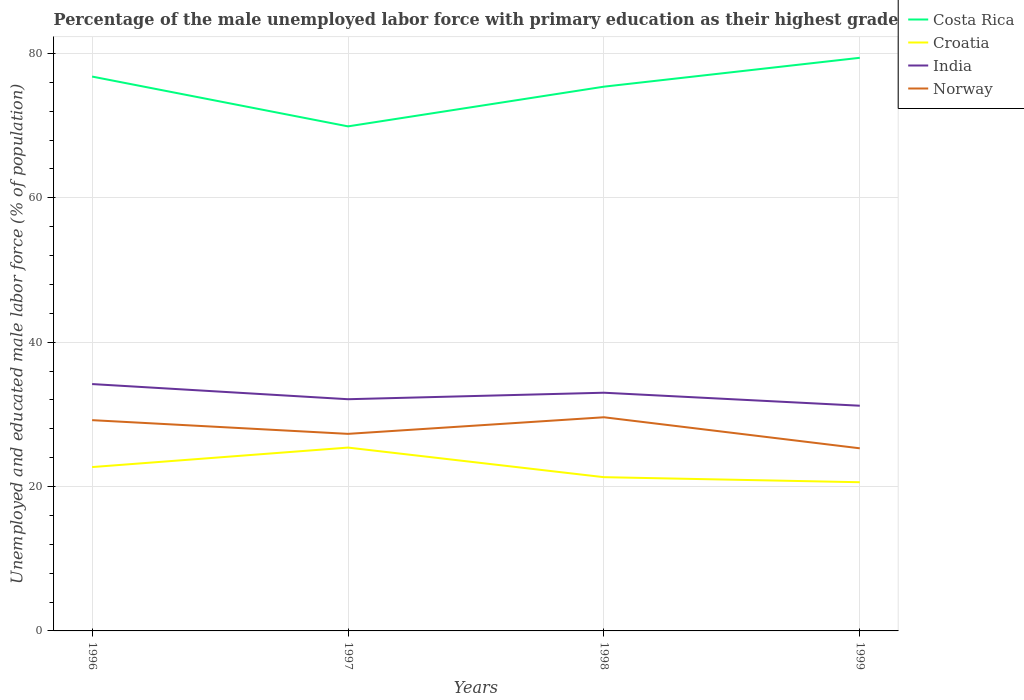Does the line corresponding to India intersect with the line corresponding to Norway?
Keep it short and to the point. No. Across all years, what is the maximum percentage of the unemployed male labor force with primary education in Norway?
Provide a short and direct response. 25.3. In which year was the percentage of the unemployed male labor force with primary education in India maximum?
Offer a very short reply. 1999. What is the total percentage of the unemployed male labor force with primary education in Costa Rica in the graph?
Your response must be concise. 6.9. What is the difference between the highest and the second highest percentage of the unemployed male labor force with primary education in India?
Ensure brevity in your answer.  3. What is the difference between the highest and the lowest percentage of the unemployed male labor force with primary education in Costa Rica?
Give a very brief answer. 3. What is the difference between two consecutive major ticks on the Y-axis?
Give a very brief answer. 20. Does the graph contain any zero values?
Give a very brief answer. No. How many legend labels are there?
Offer a terse response. 4. How are the legend labels stacked?
Your answer should be compact. Vertical. What is the title of the graph?
Keep it short and to the point. Percentage of the male unemployed labor force with primary education as their highest grade. Does "Grenada" appear as one of the legend labels in the graph?
Provide a short and direct response. No. What is the label or title of the Y-axis?
Provide a succinct answer. Unemployed and educated male labor force (% of population). What is the Unemployed and educated male labor force (% of population) of Costa Rica in 1996?
Your answer should be very brief. 76.8. What is the Unemployed and educated male labor force (% of population) in Croatia in 1996?
Give a very brief answer. 22.7. What is the Unemployed and educated male labor force (% of population) of India in 1996?
Give a very brief answer. 34.2. What is the Unemployed and educated male labor force (% of population) in Norway in 1996?
Provide a short and direct response. 29.2. What is the Unemployed and educated male labor force (% of population) in Costa Rica in 1997?
Your response must be concise. 69.9. What is the Unemployed and educated male labor force (% of population) of Croatia in 1997?
Offer a terse response. 25.4. What is the Unemployed and educated male labor force (% of population) of India in 1997?
Your answer should be very brief. 32.1. What is the Unemployed and educated male labor force (% of population) of Norway in 1997?
Provide a short and direct response. 27.3. What is the Unemployed and educated male labor force (% of population) in Costa Rica in 1998?
Your answer should be very brief. 75.4. What is the Unemployed and educated male labor force (% of population) of Croatia in 1998?
Offer a very short reply. 21.3. What is the Unemployed and educated male labor force (% of population) of Norway in 1998?
Ensure brevity in your answer.  29.6. What is the Unemployed and educated male labor force (% of population) in Costa Rica in 1999?
Your response must be concise. 79.4. What is the Unemployed and educated male labor force (% of population) of Croatia in 1999?
Provide a succinct answer. 20.6. What is the Unemployed and educated male labor force (% of population) of India in 1999?
Offer a very short reply. 31.2. What is the Unemployed and educated male labor force (% of population) of Norway in 1999?
Ensure brevity in your answer.  25.3. Across all years, what is the maximum Unemployed and educated male labor force (% of population) of Costa Rica?
Make the answer very short. 79.4. Across all years, what is the maximum Unemployed and educated male labor force (% of population) of Croatia?
Provide a short and direct response. 25.4. Across all years, what is the maximum Unemployed and educated male labor force (% of population) of India?
Give a very brief answer. 34.2. Across all years, what is the maximum Unemployed and educated male labor force (% of population) of Norway?
Provide a short and direct response. 29.6. Across all years, what is the minimum Unemployed and educated male labor force (% of population) in Costa Rica?
Give a very brief answer. 69.9. Across all years, what is the minimum Unemployed and educated male labor force (% of population) in Croatia?
Keep it short and to the point. 20.6. Across all years, what is the minimum Unemployed and educated male labor force (% of population) in India?
Ensure brevity in your answer.  31.2. Across all years, what is the minimum Unemployed and educated male labor force (% of population) of Norway?
Keep it short and to the point. 25.3. What is the total Unemployed and educated male labor force (% of population) in Costa Rica in the graph?
Keep it short and to the point. 301.5. What is the total Unemployed and educated male labor force (% of population) in India in the graph?
Keep it short and to the point. 130.5. What is the total Unemployed and educated male labor force (% of population) in Norway in the graph?
Offer a very short reply. 111.4. What is the difference between the Unemployed and educated male labor force (% of population) of Croatia in 1996 and that in 1997?
Ensure brevity in your answer.  -2.7. What is the difference between the Unemployed and educated male labor force (% of population) in India in 1996 and that in 1997?
Make the answer very short. 2.1. What is the difference between the Unemployed and educated male labor force (% of population) of Norway in 1996 and that in 1997?
Offer a very short reply. 1.9. What is the difference between the Unemployed and educated male labor force (% of population) of Norway in 1996 and that in 1998?
Provide a short and direct response. -0.4. What is the difference between the Unemployed and educated male labor force (% of population) in Costa Rica in 1996 and that in 1999?
Offer a very short reply. -2.6. What is the difference between the Unemployed and educated male labor force (% of population) of India in 1996 and that in 1999?
Ensure brevity in your answer.  3. What is the difference between the Unemployed and educated male labor force (% of population) in Costa Rica in 1997 and that in 1998?
Your answer should be very brief. -5.5. What is the difference between the Unemployed and educated male labor force (% of population) in Croatia in 1997 and that in 1998?
Offer a very short reply. 4.1. What is the difference between the Unemployed and educated male labor force (% of population) of India in 1997 and that in 1998?
Keep it short and to the point. -0.9. What is the difference between the Unemployed and educated male labor force (% of population) in Croatia in 1997 and that in 1999?
Your answer should be very brief. 4.8. What is the difference between the Unemployed and educated male labor force (% of population) in Norway in 1997 and that in 1999?
Your answer should be compact. 2. What is the difference between the Unemployed and educated male labor force (% of population) of India in 1998 and that in 1999?
Keep it short and to the point. 1.8. What is the difference between the Unemployed and educated male labor force (% of population) in Costa Rica in 1996 and the Unemployed and educated male labor force (% of population) in Croatia in 1997?
Offer a terse response. 51.4. What is the difference between the Unemployed and educated male labor force (% of population) in Costa Rica in 1996 and the Unemployed and educated male labor force (% of population) in India in 1997?
Your answer should be compact. 44.7. What is the difference between the Unemployed and educated male labor force (% of population) in Costa Rica in 1996 and the Unemployed and educated male labor force (% of population) in Norway in 1997?
Ensure brevity in your answer.  49.5. What is the difference between the Unemployed and educated male labor force (% of population) in Croatia in 1996 and the Unemployed and educated male labor force (% of population) in Norway in 1997?
Your answer should be compact. -4.6. What is the difference between the Unemployed and educated male labor force (% of population) of Costa Rica in 1996 and the Unemployed and educated male labor force (% of population) of Croatia in 1998?
Your answer should be compact. 55.5. What is the difference between the Unemployed and educated male labor force (% of population) in Costa Rica in 1996 and the Unemployed and educated male labor force (% of population) in India in 1998?
Offer a terse response. 43.8. What is the difference between the Unemployed and educated male labor force (% of population) of Costa Rica in 1996 and the Unemployed and educated male labor force (% of population) of Norway in 1998?
Provide a succinct answer. 47.2. What is the difference between the Unemployed and educated male labor force (% of population) in Croatia in 1996 and the Unemployed and educated male labor force (% of population) in Norway in 1998?
Provide a succinct answer. -6.9. What is the difference between the Unemployed and educated male labor force (% of population) of Costa Rica in 1996 and the Unemployed and educated male labor force (% of population) of Croatia in 1999?
Give a very brief answer. 56.2. What is the difference between the Unemployed and educated male labor force (% of population) in Costa Rica in 1996 and the Unemployed and educated male labor force (% of population) in India in 1999?
Keep it short and to the point. 45.6. What is the difference between the Unemployed and educated male labor force (% of population) in Costa Rica in 1996 and the Unemployed and educated male labor force (% of population) in Norway in 1999?
Make the answer very short. 51.5. What is the difference between the Unemployed and educated male labor force (% of population) of Croatia in 1996 and the Unemployed and educated male labor force (% of population) of India in 1999?
Give a very brief answer. -8.5. What is the difference between the Unemployed and educated male labor force (% of population) in Costa Rica in 1997 and the Unemployed and educated male labor force (% of population) in Croatia in 1998?
Your answer should be very brief. 48.6. What is the difference between the Unemployed and educated male labor force (% of population) in Costa Rica in 1997 and the Unemployed and educated male labor force (% of population) in India in 1998?
Keep it short and to the point. 36.9. What is the difference between the Unemployed and educated male labor force (% of population) of Costa Rica in 1997 and the Unemployed and educated male labor force (% of population) of Norway in 1998?
Offer a terse response. 40.3. What is the difference between the Unemployed and educated male labor force (% of population) in Costa Rica in 1997 and the Unemployed and educated male labor force (% of population) in Croatia in 1999?
Offer a terse response. 49.3. What is the difference between the Unemployed and educated male labor force (% of population) in Costa Rica in 1997 and the Unemployed and educated male labor force (% of population) in India in 1999?
Provide a succinct answer. 38.7. What is the difference between the Unemployed and educated male labor force (% of population) of Costa Rica in 1997 and the Unemployed and educated male labor force (% of population) of Norway in 1999?
Your answer should be very brief. 44.6. What is the difference between the Unemployed and educated male labor force (% of population) in Croatia in 1997 and the Unemployed and educated male labor force (% of population) in Norway in 1999?
Give a very brief answer. 0.1. What is the difference between the Unemployed and educated male labor force (% of population) in India in 1997 and the Unemployed and educated male labor force (% of population) in Norway in 1999?
Provide a short and direct response. 6.8. What is the difference between the Unemployed and educated male labor force (% of population) of Costa Rica in 1998 and the Unemployed and educated male labor force (% of population) of Croatia in 1999?
Keep it short and to the point. 54.8. What is the difference between the Unemployed and educated male labor force (% of population) of Costa Rica in 1998 and the Unemployed and educated male labor force (% of population) of India in 1999?
Your answer should be compact. 44.2. What is the difference between the Unemployed and educated male labor force (% of population) in Costa Rica in 1998 and the Unemployed and educated male labor force (% of population) in Norway in 1999?
Your answer should be very brief. 50.1. What is the average Unemployed and educated male labor force (% of population) of Costa Rica per year?
Give a very brief answer. 75.38. What is the average Unemployed and educated male labor force (% of population) of India per year?
Give a very brief answer. 32.62. What is the average Unemployed and educated male labor force (% of population) in Norway per year?
Provide a succinct answer. 27.85. In the year 1996, what is the difference between the Unemployed and educated male labor force (% of population) of Costa Rica and Unemployed and educated male labor force (% of population) of Croatia?
Make the answer very short. 54.1. In the year 1996, what is the difference between the Unemployed and educated male labor force (% of population) in Costa Rica and Unemployed and educated male labor force (% of population) in India?
Your answer should be compact. 42.6. In the year 1996, what is the difference between the Unemployed and educated male labor force (% of population) in Costa Rica and Unemployed and educated male labor force (% of population) in Norway?
Provide a succinct answer. 47.6. In the year 1996, what is the difference between the Unemployed and educated male labor force (% of population) in Croatia and Unemployed and educated male labor force (% of population) in India?
Ensure brevity in your answer.  -11.5. In the year 1996, what is the difference between the Unemployed and educated male labor force (% of population) of Croatia and Unemployed and educated male labor force (% of population) of Norway?
Provide a short and direct response. -6.5. In the year 1996, what is the difference between the Unemployed and educated male labor force (% of population) in India and Unemployed and educated male labor force (% of population) in Norway?
Your answer should be compact. 5. In the year 1997, what is the difference between the Unemployed and educated male labor force (% of population) in Costa Rica and Unemployed and educated male labor force (% of population) in Croatia?
Offer a very short reply. 44.5. In the year 1997, what is the difference between the Unemployed and educated male labor force (% of population) in Costa Rica and Unemployed and educated male labor force (% of population) in India?
Offer a terse response. 37.8. In the year 1997, what is the difference between the Unemployed and educated male labor force (% of population) in Costa Rica and Unemployed and educated male labor force (% of population) in Norway?
Keep it short and to the point. 42.6. In the year 1997, what is the difference between the Unemployed and educated male labor force (% of population) in Croatia and Unemployed and educated male labor force (% of population) in India?
Offer a terse response. -6.7. In the year 1998, what is the difference between the Unemployed and educated male labor force (% of population) in Costa Rica and Unemployed and educated male labor force (% of population) in Croatia?
Offer a very short reply. 54.1. In the year 1998, what is the difference between the Unemployed and educated male labor force (% of population) in Costa Rica and Unemployed and educated male labor force (% of population) in India?
Give a very brief answer. 42.4. In the year 1998, what is the difference between the Unemployed and educated male labor force (% of population) of Costa Rica and Unemployed and educated male labor force (% of population) of Norway?
Your answer should be very brief. 45.8. In the year 1999, what is the difference between the Unemployed and educated male labor force (% of population) in Costa Rica and Unemployed and educated male labor force (% of population) in Croatia?
Offer a terse response. 58.8. In the year 1999, what is the difference between the Unemployed and educated male labor force (% of population) in Costa Rica and Unemployed and educated male labor force (% of population) in India?
Give a very brief answer. 48.2. In the year 1999, what is the difference between the Unemployed and educated male labor force (% of population) in Costa Rica and Unemployed and educated male labor force (% of population) in Norway?
Provide a succinct answer. 54.1. In the year 1999, what is the difference between the Unemployed and educated male labor force (% of population) of Croatia and Unemployed and educated male labor force (% of population) of India?
Your answer should be very brief. -10.6. In the year 1999, what is the difference between the Unemployed and educated male labor force (% of population) in Croatia and Unemployed and educated male labor force (% of population) in Norway?
Give a very brief answer. -4.7. In the year 1999, what is the difference between the Unemployed and educated male labor force (% of population) in India and Unemployed and educated male labor force (% of population) in Norway?
Ensure brevity in your answer.  5.9. What is the ratio of the Unemployed and educated male labor force (% of population) of Costa Rica in 1996 to that in 1997?
Give a very brief answer. 1.1. What is the ratio of the Unemployed and educated male labor force (% of population) of Croatia in 1996 to that in 1997?
Keep it short and to the point. 0.89. What is the ratio of the Unemployed and educated male labor force (% of population) in India in 1996 to that in 1997?
Keep it short and to the point. 1.07. What is the ratio of the Unemployed and educated male labor force (% of population) of Norway in 1996 to that in 1997?
Ensure brevity in your answer.  1.07. What is the ratio of the Unemployed and educated male labor force (% of population) of Costa Rica in 1996 to that in 1998?
Keep it short and to the point. 1.02. What is the ratio of the Unemployed and educated male labor force (% of population) in Croatia in 1996 to that in 1998?
Provide a short and direct response. 1.07. What is the ratio of the Unemployed and educated male labor force (% of population) of India in 1996 to that in 1998?
Provide a succinct answer. 1.04. What is the ratio of the Unemployed and educated male labor force (% of population) in Norway in 1996 to that in 1998?
Provide a short and direct response. 0.99. What is the ratio of the Unemployed and educated male labor force (% of population) of Costa Rica in 1996 to that in 1999?
Provide a short and direct response. 0.97. What is the ratio of the Unemployed and educated male labor force (% of population) in Croatia in 1996 to that in 1999?
Your answer should be compact. 1.1. What is the ratio of the Unemployed and educated male labor force (% of population) in India in 1996 to that in 1999?
Your response must be concise. 1.1. What is the ratio of the Unemployed and educated male labor force (% of population) in Norway in 1996 to that in 1999?
Give a very brief answer. 1.15. What is the ratio of the Unemployed and educated male labor force (% of population) of Costa Rica in 1997 to that in 1998?
Your answer should be very brief. 0.93. What is the ratio of the Unemployed and educated male labor force (% of population) of Croatia in 1997 to that in 1998?
Ensure brevity in your answer.  1.19. What is the ratio of the Unemployed and educated male labor force (% of population) of India in 1997 to that in 1998?
Keep it short and to the point. 0.97. What is the ratio of the Unemployed and educated male labor force (% of population) in Norway in 1997 to that in 1998?
Offer a very short reply. 0.92. What is the ratio of the Unemployed and educated male labor force (% of population) of Costa Rica in 1997 to that in 1999?
Offer a terse response. 0.88. What is the ratio of the Unemployed and educated male labor force (% of population) in Croatia in 1997 to that in 1999?
Your answer should be very brief. 1.23. What is the ratio of the Unemployed and educated male labor force (% of population) of India in 1997 to that in 1999?
Keep it short and to the point. 1.03. What is the ratio of the Unemployed and educated male labor force (% of population) in Norway in 1997 to that in 1999?
Your answer should be very brief. 1.08. What is the ratio of the Unemployed and educated male labor force (% of population) in Costa Rica in 1998 to that in 1999?
Make the answer very short. 0.95. What is the ratio of the Unemployed and educated male labor force (% of population) of Croatia in 1998 to that in 1999?
Ensure brevity in your answer.  1.03. What is the ratio of the Unemployed and educated male labor force (% of population) in India in 1998 to that in 1999?
Give a very brief answer. 1.06. What is the ratio of the Unemployed and educated male labor force (% of population) of Norway in 1998 to that in 1999?
Keep it short and to the point. 1.17. What is the difference between the highest and the second highest Unemployed and educated male labor force (% of population) in Costa Rica?
Give a very brief answer. 2.6. What is the difference between the highest and the lowest Unemployed and educated male labor force (% of population) of Costa Rica?
Your answer should be very brief. 9.5. What is the difference between the highest and the lowest Unemployed and educated male labor force (% of population) in Croatia?
Keep it short and to the point. 4.8. What is the difference between the highest and the lowest Unemployed and educated male labor force (% of population) in Norway?
Your response must be concise. 4.3. 